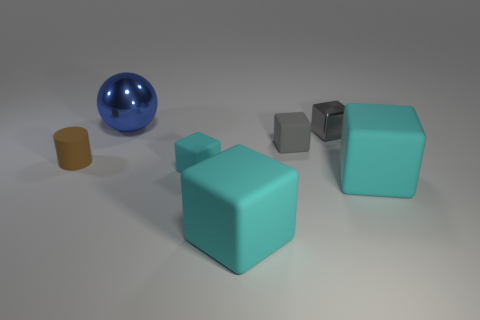Is the number of shiny blocks greater than the number of big cyan blocks?
Your answer should be very brief. No. Is there any other thing that has the same color as the rubber cylinder?
Your response must be concise. No. Is the brown cylinder made of the same material as the tiny cyan thing?
Your answer should be very brief. Yes. Is the number of large red metal blocks less than the number of gray shiny blocks?
Provide a succinct answer. Yes. Do the tiny metallic thing and the tiny cyan matte thing have the same shape?
Provide a short and direct response. Yes. The big metal ball has what color?
Keep it short and to the point. Blue. What number of other things are the same material as the cylinder?
Offer a terse response. 4. What number of cyan things are either big matte things or balls?
Provide a short and direct response. 2. Is the shape of the tiny rubber object that is left of the large shiny sphere the same as the metal thing behind the tiny metallic block?
Keep it short and to the point. No. There is a metal block; is its color the same as the tiny rubber cube that is behind the small brown cylinder?
Offer a terse response. Yes. 